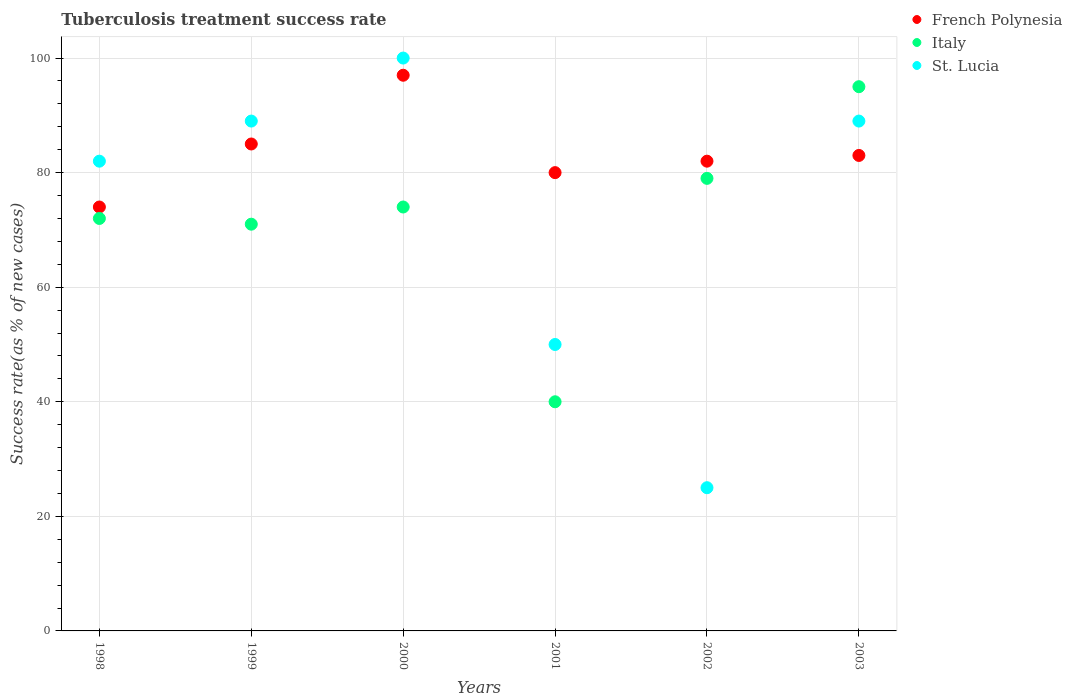Is the number of dotlines equal to the number of legend labels?
Your response must be concise. Yes. What is the tuberculosis treatment success rate in French Polynesia in 2002?
Offer a terse response. 82. Across all years, what is the minimum tuberculosis treatment success rate in Italy?
Provide a succinct answer. 40. In which year was the tuberculosis treatment success rate in St. Lucia maximum?
Ensure brevity in your answer.  2000. What is the total tuberculosis treatment success rate in French Polynesia in the graph?
Offer a very short reply. 501. What is the difference between the tuberculosis treatment success rate in Italy in 1999 and that in 2000?
Your response must be concise. -3. What is the average tuberculosis treatment success rate in Italy per year?
Keep it short and to the point. 71.83. In the year 1998, what is the difference between the tuberculosis treatment success rate in St. Lucia and tuberculosis treatment success rate in French Polynesia?
Keep it short and to the point. 8. In how many years, is the tuberculosis treatment success rate in French Polynesia greater than 32 %?
Make the answer very short. 6. Is the tuberculosis treatment success rate in St. Lucia in 2001 less than that in 2003?
Offer a very short reply. Yes. Is the difference between the tuberculosis treatment success rate in St. Lucia in 2000 and 2002 greater than the difference between the tuberculosis treatment success rate in French Polynesia in 2000 and 2002?
Your response must be concise. Yes. What is the difference between the highest and the second highest tuberculosis treatment success rate in Italy?
Your answer should be compact. 16. Is it the case that in every year, the sum of the tuberculosis treatment success rate in St. Lucia and tuberculosis treatment success rate in French Polynesia  is greater than the tuberculosis treatment success rate in Italy?
Keep it short and to the point. Yes. Does the tuberculosis treatment success rate in Italy monotonically increase over the years?
Ensure brevity in your answer.  No. Is the tuberculosis treatment success rate in French Polynesia strictly greater than the tuberculosis treatment success rate in Italy over the years?
Your answer should be compact. No. How many dotlines are there?
Offer a very short reply. 3. What is the difference between two consecutive major ticks on the Y-axis?
Provide a succinct answer. 20. Does the graph contain any zero values?
Make the answer very short. No. How many legend labels are there?
Provide a succinct answer. 3. How are the legend labels stacked?
Provide a short and direct response. Vertical. What is the title of the graph?
Provide a succinct answer. Tuberculosis treatment success rate. Does "High income: nonOECD" appear as one of the legend labels in the graph?
Keep it short and to the point. No. What is the label or title of the Y-axis?
Your response must be concise. Success rate(as % of new cases). What is the Success rate(as % of new cases) of Italy in 1998?
Provide a short and direct response. 72. What is the Success rate(as % of new cases) in St. Lucia in 1998?
Provide a succinct answer. 82. What is the Success rate(as % of new cases) in French Polynesia in 1999?
Make the answer very short. 85. What is the Success rate(as % of new cases) in St. Lucia in 1999?
Your answer should be compact. 89. What is the Success rate(as % of new cases) of French Polynesia in 2000?
Offer a terse response. 97. What is the Success rate(as % of new cases) in Italy in 2000?
Provide a short and direct response. 74. What is the Success rate(as % of new cases) in St. Lucia in 2000?
Keep it short and to the point. 100. What is the Success rate(as % of new cases) in French Polynesia in 2001?
Your answer should be compact. 80. What is the Success rate(as % of new cases) in Italy in 2001?
Provide a short and direct response. 40. What is the Success rate(as % of new cases) of St. Lucia in 2001?
Your answer should be very brief. 50. What is the Success rate(as % of new cases) in French Polynesia in 2002?
Make the answer very short. 82. What is the Success rate(as % of new cases) in Italy in 2002?
Your answer should be very brief. 79. What is the Success rate(as % of new cases) in St. Lucia in 2002?
Provide a short and direct response. 25. What is the Success rate(as % of new cases) in St. Lucia in 2003?
Keep it short and to the point. 89. Across all years, what is the maximum Success rate(as % of new cases) of French Polynesia?
Make the answer very short. 97. Across all years, what is the minimum Success rate(as % of new cases) of Italy?
Provide a succinct answer. 40. What is the total Success rate(as % of new cases) in French Polynesia in the graph?
Keep it short and to the point. 501. What is the total Success rate(as % of new cases) in Italy in the graph?
Offer a very short reply. 431. What is the total Success rate(as % of new cases) in St. Lucia in the graph?
Give a very brief answer. 435. What is the difference between the Success rate(as % of new cases) in French Polynesia in 1998 and that in 1999?
Offer a terse response. -11. What is the difference between the Success rate(as % of new cases) of Italy in 1998 and that in 1999?
Provide a succinct answer. 1. What is the difference between the Success rate(as % of new cases) of St. Lucia in 1998 and that in 1999?
Ensure brevity in your answer.  -7. What is the difference between the Success rate(as % of new cases) of French Polynesia in 1998 and that in 2000?
Provide a succinct answer. -23. What is the difference between the Success rate(as % of new cases) in St. Lucia in 1998 and that in 2000?
Your answer should be compact. -18. What is the difference between the Success rate(as % of new cases) in Italy in 1998 and that in 2001?
Your answer should be very brief. 32. What is the difference between the Success rate(as % of new cases) in French Polynesia in 1998 and that in 2002?
Offer a terse response. -8. What is the difference between the Success rate(as % of new cases) of French Polynesia in 1998 and that in 2003?
Offer a very short reply. -9. What is the difference between the Success rate(as % of new cases) of Italy in 1998 and that in 2003?
Ensure brevity in your answer.  -23. What is the difference between the Success rate(as % of new cases) in St. Lucia in 1998 and that in 2003?
Your answer should be compact. -7. What is the difference between the Success rate(as % of new cases) of French Polynesia in 1999 and that in 2000?
Your response must be concise. -12. What is the difference between the Success rate(as % of new cases) of St. Lucia in 1999 and that in 2000?
Provide a succinct answer. -11. What is the difference between the Success rate(as % of new cases) of St. Lucia in 1999 and that in 2001?
Keep it short and to the point. 39. What is the difference between the Success rate(as % of new cases) of French Polynesia in 1999 and that in 2003?
Make the answer very short. 2. What is the difference between the Success rate(as % of new cases) of Italy in 1999 and that in 2003?
Offer a very short reply. -24. What is the difference between the Success rate(as % of new cases) of French Polynesia in 2000 and that in 2001?
Give a very brief answer. 17. What is the difference between the Success rate(as % of new cases) in Italy in 2000 and that in 2001?
Provide a succinct answer. 34. What is the difference between the Success rate(as % of new cases) of St. Lucia in 2000 and that in 2001?
Make the answer very short. 50. What is the difference between the Success rate(as % of new cases) in French Polynesia in 2000 and that in 2002?
Offer a terse response. 15. What is the difference between the Success rate(as % of new cases) in French Polynesia in 2000 and that in 2003?
Ensure brevity in your answer.  14. What is the difference between the Success rate(as % of new cases) of St. Lucia in 2000 and that in 2003?
Make the answer very short. 11. What is the difference between the Success rate(as % of new cases) of French Polynesia in 2001 and that in 2002?
Offer a very short reply. -2. What is the difference between the Success rate(as % of new cases) of Italy in 2001 and that in 2002?
Provide a succinct answer. -39. What is the difference between the Success rate(as % of new cases) in St. Lucia in 2001 and that in 2002?
Ensure brevity in your answer.  25. What is the difference between the Success rate(as % of new cases) in Italy in 2001 and that in 2003?
Provide a succinct answer. -55. What is the difference between the Success rate(as % of new cases) of St. Lucia in 2001 and that in 2003?
Offer a terse response. -39. What is the difference between the Success rate(as % of new cases) in Italy in 2002 and that in 2003?
Ensure brevity in your answer.  -16. What is the difference between the Success rate(as % of new cases) in St. Lucia in 2002 and that in 2003?
Give a very brief answer. -64. What is the difference between the Success rate(as % of new cases) in French Polynesia in 1998 and the Success rate(as % of new cases) in Italy in 1999?
Your answer should be very brief. 3. What is the difference between the Success rate(as % of new cases) of French Polynesia in 1998 and the Success rate(as % of new cases) of Italy in 2001?
Provide a short and direct response. 34. What is the difference between the Success rate(as % of new cases) of French Polynesia in 1998 and the Success rate(as % of new cases) of St. Lucia in 2001?
Give a very brief answer. 24. What is the difference between the Success rate(as % of new cases) in Italy in 1998 and the Success rate(as % of new cases) in St. Lucia in 2001?
Your response must be concise. 22. What is the difference between the Success rate(as % of new cases) in French Polynesia in 1998 and the Success rate(as % of new cases) in Italy in 2002?
Give a very brief answer. -5. What is the difference between the Success rate(as % of new cases) in French Polynesia in 1998 and the Success rate(as % of new cases) in St. Lucia in 2002?
Offer a very short reply. 49. What is the difference between the Success rate(as % of new cases) of French Polynesia in 1998 and the Success rate(as % of new cases) of St. Lucia in 2003?
Make the answer very short. -15. What is the difference between the Success rate(as % of new cases) of Italy in 1998 and the Success rate(as % of new cases) of St. Lucia in 2003?
Keep it short and to the point. -17. What is the difference between the Success rate(as % of new cases) of French Polynesia in 1999 and the Success rate(as % of new cases) of Italy in 2000?
Offer a very short reply. 11. What is the difference between the Success rate(as % of new cases) of French Polynesia in 1999 and the Success rate(as % of new cases) of St. Lucia in 2000?
Provide a succinct answer. -15. What is the difference between the Success rate(as % of new cases) of French Polynesia in 1999 and the Success rate(as % of new cases) of St. Lucia in 2001?
Make the answer very short. 35. What is the difference between the Success rate(as % of new cases) of Italy in 1999 and the Success rate(as % of new cases) of St. Lucia in 2001?
Keep it short and to the point. 21. What is the difference between the Success rate(as % of new cases) in French Polynesia in 1999 and the Success rate(as % of new cases) in St. Lucia in 2002?
Give a very brief answer. 60. What is the difference between the Success rate(as % of new cases) in French Polynesia in 2000 and the Success rate(as % of new cases) in Italy in 2001?
Make the answer very short. 57. What is the difference between the Success rate(as % of new cases) of Italy in 2000 and the Success rate(as % of new cases) of St. Lucia in 2002?
Make the answer very short. 49. What is the difference between the Success rate(as % of new cases) in French Polynesia in 2000 and the Success rate(as % of new cases) in Italy in 2003?
Your answer should be very brief. 2. What is the difference between the Success rate(as % of new cases) in French Polynesia in 2000 and the Success rate(as % of new cases) in St. Lucia in 2003?
Offer a very short reply. 8. What is the difference between the Success rate(as % of new cases) of Italy in 2000 and the Success rate(as % of new cases) of St. Lucia in 2003?
Ensure brevity in your answer.  -15. What is the difference between the Success rate(as % of new cases) of French Polynesia in 2001 and the Success rate(as % of new cases) of Italy in 2002?
Ensure brevity in your answer.  1. What is the difference between the Success rate(as % of new cases) of French Polynesia in 2001 and the Success rate(as % of new cases) of St. Lucia in 2002?
Make the answer very short. 55. What is the difference between the Success rate(as % of new cases) of Italy in 2001 and the Success rate(as % of new cases) of St. Lucia in 2002?
Provide a short and direct response. 15. What is the difference between the Success rate(as % of new cases) of French Polynesia in 2001 and the Success rate(as % of new cases) of St. Lucia in 2003?
Keep it short and to the point. -9. What is the difference between the Success rate(as % of new cases) of Italy in 2001 and the Success rate(as % of new cases) of St. Lucia in 2003?
Offer a terse response. -49. What is the difference between the Success rate(as % of new cases) in French Polynesia in 2002 and the Success rate(as % of new cases) in Italy in 2003?
Your response must be concise. -13. What is the difference between the Success rate(as % of new cases) of Italy in 2002 and the Success rate(as % of new cases) of St. Lucia in 2003?
Keep it short and to the point. -10. What is the average Success rate(as % of new cases) in French Polynesia per year?
Keep it short and to the point. 83.5. What is the average Success rate(as % of new cases) of Italy per year?
Give a very brief answer. 71.83. What is the average Success rate(as % of new cases) of St. Lucia per year?
Your response must be concise. 72.5. In the year 1998, what is the difference between the Success rate(as % of new cases) of Italy and Success rate(as % of new cases) of St. Lucia?
Offer a very short reply. -10. In the year 1999, what is the difference between the Success rate(as % of new cases) of French Polynesia and Success rate(as % of new cases) of Italy?
Provide a succinct answer. 14. In the year 1999, what is the difference between the Success rate(as % of new cases) in French Polynesia and Success rate(as % of new cases) in St. Lucia?
Your answer should be compact. -4. In the year 1999, what is the difference between the Success rate(as % of new cases) in Italy and Success rate(as % of new cases) in St. Lucia?
Your answer should be compact. -18. In the year 2000, what is the difference between the Success rate(as % of new cases) of French Polynesia and Success rate(as % of new cases) of St. Lucia?
Keep it short and to the point. -3. In the year 2000, what is the difference between the Success rate(as % of new cases) of Italy and Success rate(as % of new cases) of St. Lucia?
Ensure brevity in your answer.  -26. In the year 2001, what is the difference between the Success rate(as % of new cases) in French Polynesia and Success rate(as % of new cases) in Italy?
Offer a terse response. 40. In the year 2003, what is the difference between the Success rate(as % of new cases) of French Polynesia and Success rate(as % of new cases) of Italy?
Provide a succinct answer. -12. In the year 2003, what is the difference between the Success rate(as % of new cases) of Italy and Success rate(as % of new cases) of St. Lucia?
Your answer should be compact. 6. What is the ratio of the Success rate(as % of new cases) in French Polynesia in 1998 to that in 1999?
Offer a very short reply. 0.87. What is the ratio of the Success rate(as % of new cases) in Italy in 1998 to that in 1999?
Offer a very short reply. 1.01. What is the ratio of the Success rate(as % of new cases) of St. Lucia in 1998 to that in 1999?
Offer a very short reply. 0.92. What is the ratio of the Success rate(as % of new cases) in French Polynesia in 1998 to that in 2000?
Ensure brevity in your answer.  0.76. What is the ratio of the Success rate(as % of new cases) in Italy in 1998 to that in 2000?
Make the answer very short. 0.97. What is the ratio of the Success rate(as % of new cases) of St. Lucia in 1998 to that in 2000?
Provide a short and direct response. 0.82. What is the ratio of the Success rate(as % of new cases) of French Polynesia in 1998 to that in 2001?
Provide a succinct answer. 0.93. What is the ratio of the Success rate(as % of new cases) of Italy in 1998 to that in 2001?
Your answer should be compact. 1.8. What is the ratio of the Success rate(as % of new cases) in St. Lucia in 1998 to that in 2001?
Ensure brevity in your answer.  1.64. What is the ratio of the Success rate(as % of new cases) in French Polynesia in 1998 to that in 2002?
Provide a short and direct response. 0.9. What is the ratio of the Success rate(as % of new cases) in Italy in 1998 to that in 2002?
Your answer should be very brief. 0.91. What is the ratio of the Success rate(as % of new cases) of St. Lucia in 1998 to that in 2002?
Provide a short and direct response. 3.28. What is the ratio of the Success rate(as % of new cases) of French Polynesia in 1998 to that in 2003?
Offer a very short reply. 0.89. What is the ratio of the Success rate(as % of new cases) in Italy in 1998 to that in 2003?
Provide a short and direct response. 0.76. What is the ratio of the Success rate(as % of new cases) of St. Lucia in 1998 to that in 2003?
Your response must be concise. 0.92. What is the ratio of the Success rate(as % of new cases) of French Polynesia in 1999 to that in 2000?
Give a very brief answer. 0.88. What is the ratio of the Success rate(as % of new cases) of Italy in 1999 to that in 2000?
Make the answer very short. 0.96. What is the ratio of the Success rate(as % of new cases) of St. Lucia in 1999 to that in 2000?
Keep it short and to the point. 0.89. What is the ratio of the Success rate(as % of new cases) of Italy in 1999 to that in 2001?
Make the answer very short. 1.77. What is the ratio of the Success rate(as % of new cases) of St. Lucia in 1999 to that in 2001?
Give a very brief answer. 1.78. What is the ratio of the Success rate(as % of new cases) of French Polynesia in 1999 to that in 2002?
Offer a very short reply. 1.04. What is the ratio of the Success rate(as % of new cases) in Italy in 1999 to that in 2002?
Ensure brevity in your answer.  0.9. What is the ratio of the Success rate(as % of new cases) in St. Lucia in 1999 to that in 2002?
Keep it short and to the point. 3.56. What is the ratio of the Success rate(as % of new cases) in French Polynesia in 1999 to that in 2003?
Offer a very short reply. 1.02. What is the ratio of the Success rate(as % of new cases) of Italy in 1999 to that in 2003?
Provide a succinct answer. 0.75. What is the ratio of the Success rate(as % of new cases) of French Polynesia in 2000 to that in 2001?
Offer a very short reply. 1.21. What is the ratio of the Success rate(as % of new cases) of Italy in 2000 to that in 2001?
Ensure brevity in your answer.  1.85. What is the ratio of the Success rate(as % of new cases) in St. Lucia in 2000 to that in 2001?
Offer a terse response. 2. What is the ratio of the Success rate(as % of new cases) in French Polynesia in 2000 to that in 2002?
Your answer should be very brief. 1.18. What is the ratio of the Success rate(as % of new cases) of Italy in 2000 to that in 2002?
Ensure brevity in your answer.  0.94. What is the ratio of the Success rate(as % of new cases) in St. Lucia in 2000 to that in 2002?
Offer a very short reply. 4. What is the ratio of the Success rate(as % of new cases) in French Polynesia in 2000 to that in 2003?
Provide a succinct answer. 1.17. What is the ratio of the Success rate(as % of new cases) of Italy in 2000 to that in 2003?
Provide a short and direct response. 0.78. What is the ratio of the Success rate(as % of new cases) of St. Lucia in 2000 to that in 2003?
Provide a succinct answer. 1.12. What is the ratio of the Success rate(as % of new cases) in French Polynesia in 2001 to that in 2002?
Keep it short and to the point. 0.98. What is the ratio of the Success rate(as % of new cases) of Italy in 2001 to that in 2002?
Your response must be concise. 0.51. What is the ratio of the Success rate(as % of new cases) in French Polynesia in 2001 to that in 2003?
Make the answer very short. 0.96. What is the ratio of the Success rate(as % of new cases) in Italy in 2001 to that in 2003?
Your answer should be compact. 0.42. What is the ratio of the Success rate(as % of new cases) in St. Lucia in 2001 to that in 2003?
Your answer should be very brief. 0.56. What is the ratio of the Success rate(as % of new cases) in Italy in 2002 to that in 2003?
Provide a short and direct response. 0.83. What is the ratio of the Success rate(as % of new cases) in St. Lucia in 2002 to that in 2003?
Your response must be concise. 0.28. What is the difference between the highest and the second highest Success rate(as % of new cases) of French Polynesia?
Your response must be concise. 12. What is the difference between the highest and the second highest Success rate(as % of new cases) in St. Lucia?
Your answer should be very brief. 11. What is the difference between the highest and the lowest Success rate(as % of new cases) of French Polynesia?
Your answer should be very brief. 23. 